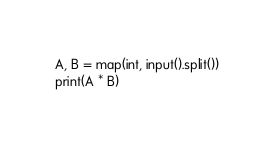Convert code to text. <code><loc_0><loc_0><loc_500><loc_500><_Python_>A, B = map(int, input().split())
print(A * B)</code> 